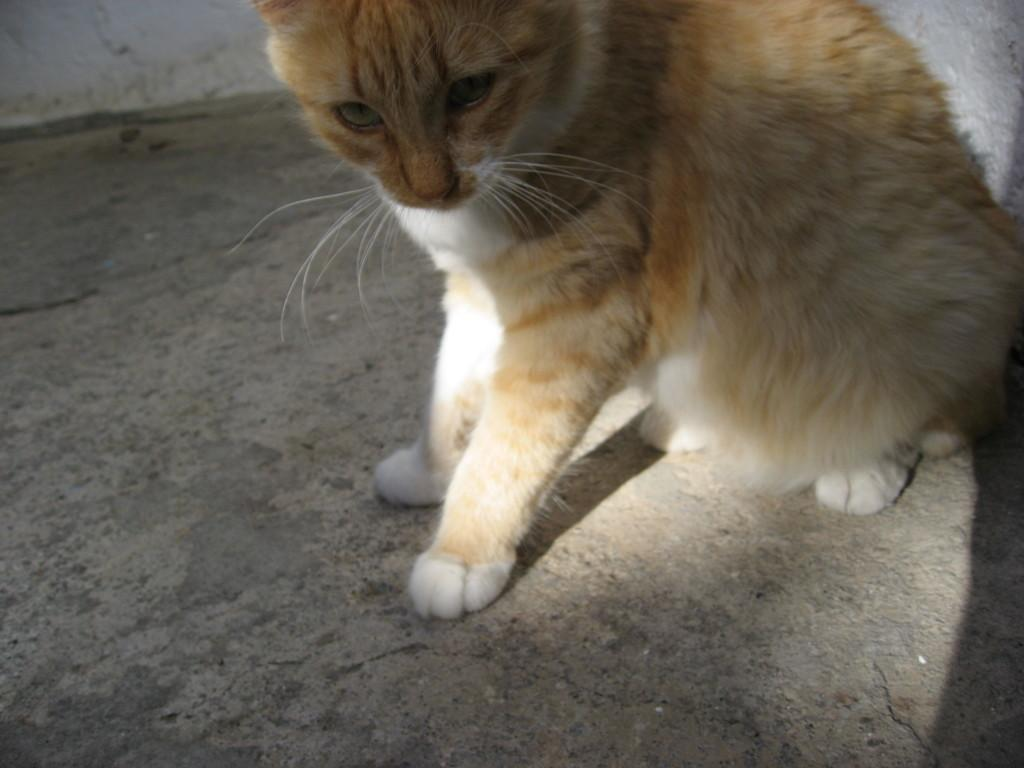What type of animal is in the image? There is a cat in the image. What type of flooring is visible in the image? There is a cement floor in the image. What type of pest can be seen on the school scale in the image? There is no school or scale present in the image; it only features a cat and a cement floor. 